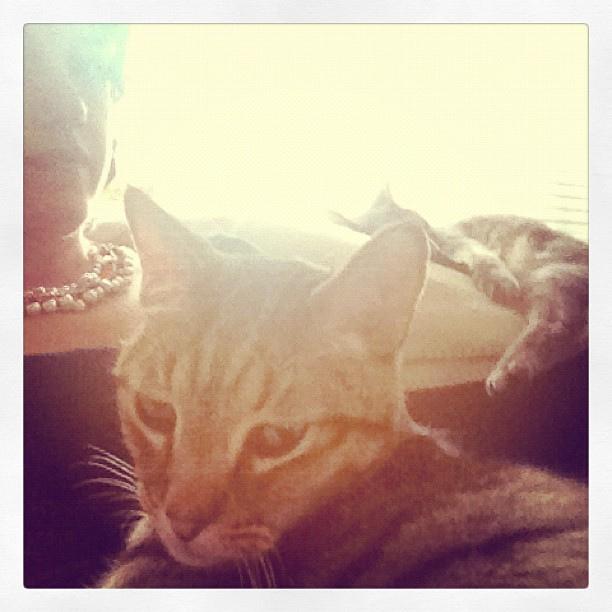Why is the cat moody?
Keep it brief. Tired. Is this cat long-faced?
Answer briefly. Yes. Is there lens flare in this photo?
Be succinct. Yes. 